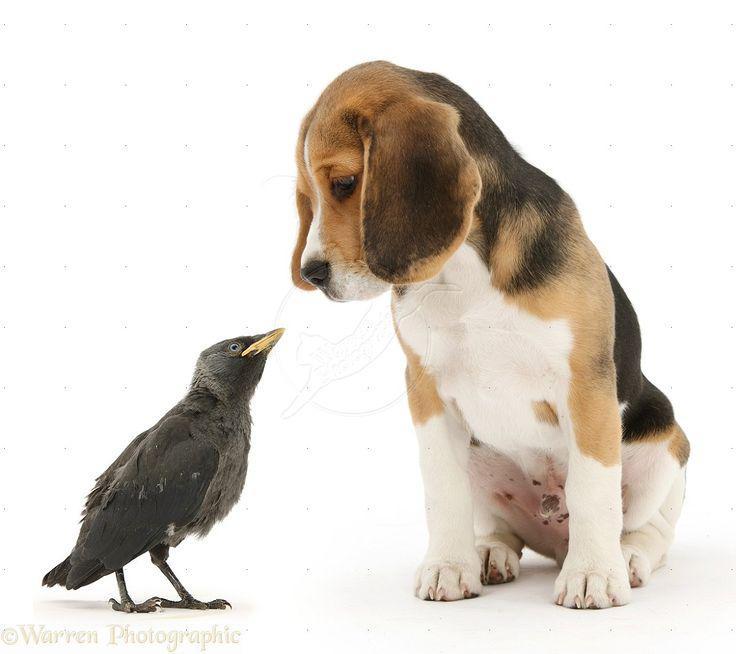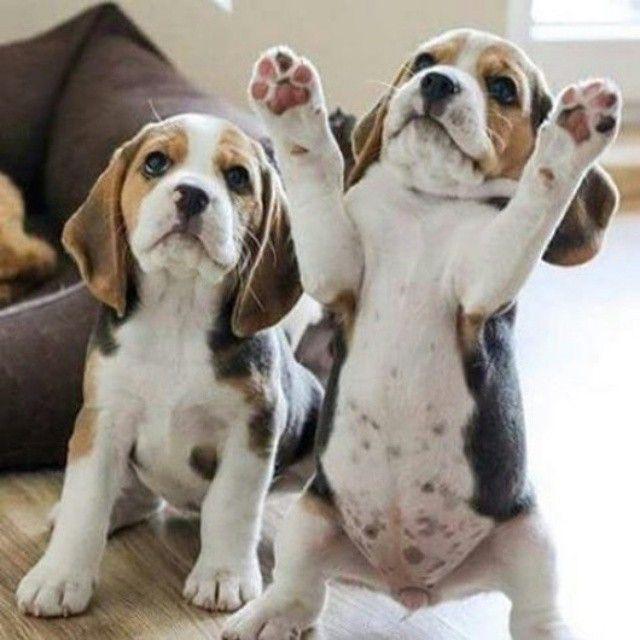The first image is the image on the left, the second image is the image on the right. Examine the images to the left and right. Is the description "The dogs in the image on the right are sitting on the ground outside." accurate? Answer yes or no. No. The first image is the image on the left, the second image is the image on the right. Assess this claim about the two images: "There are 2 dogs standing on all fours in the right image.". Correct or not? Answer yes or no. No. 